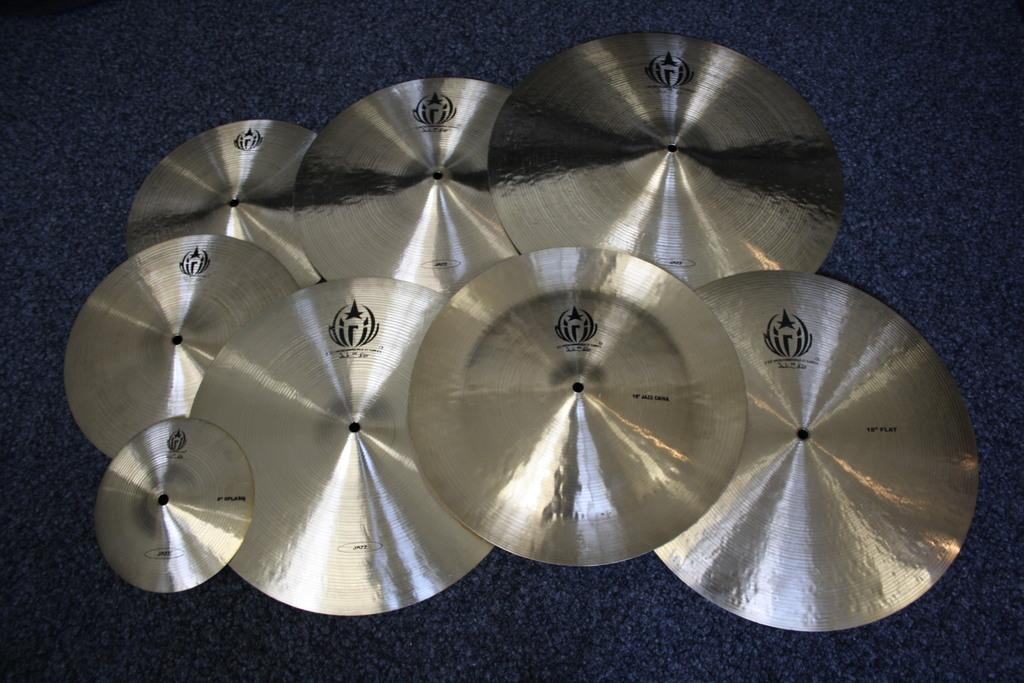What objects are present on the blue color cloth in the image? There are metal discs on the blue color cloth in the image. What is the color of the cloth that the metal discs are placed on? The cloth is blue in color. What type of mass is being conducted in the image? There is no indication of a mass or any religious ceremony in the image; it only features metal discs on a blue color cloth. 